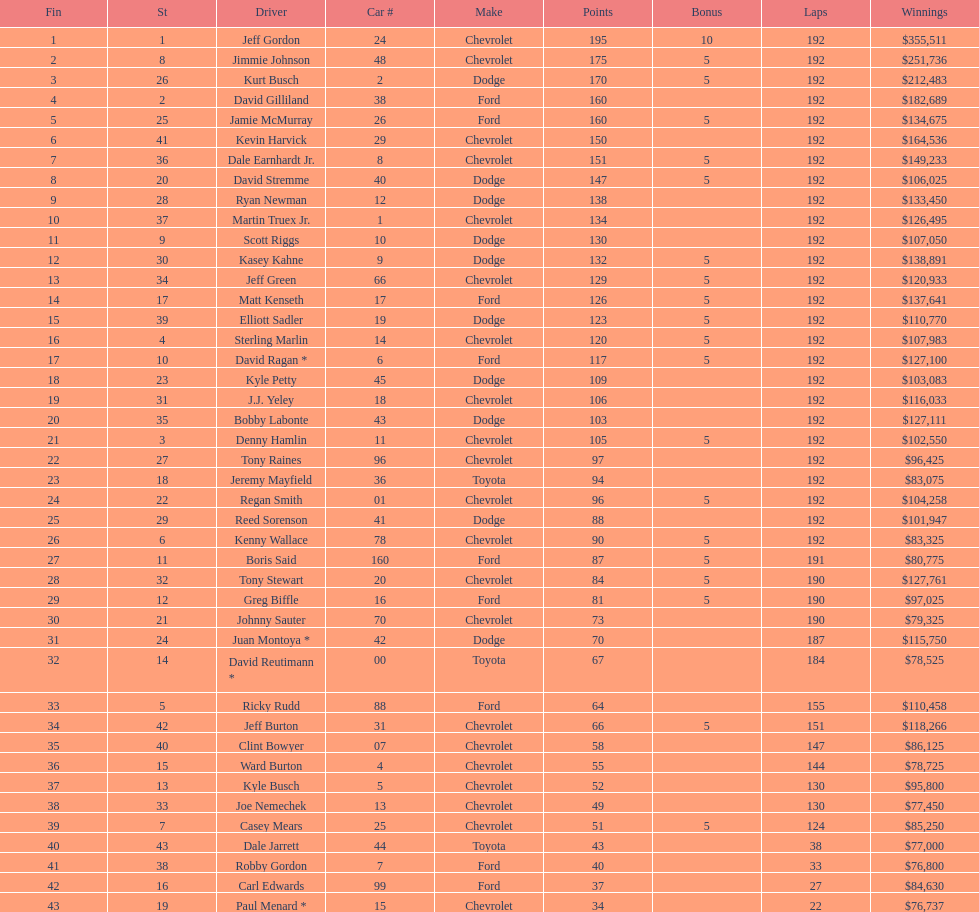How many drivers placed below tony stewart? 15. 